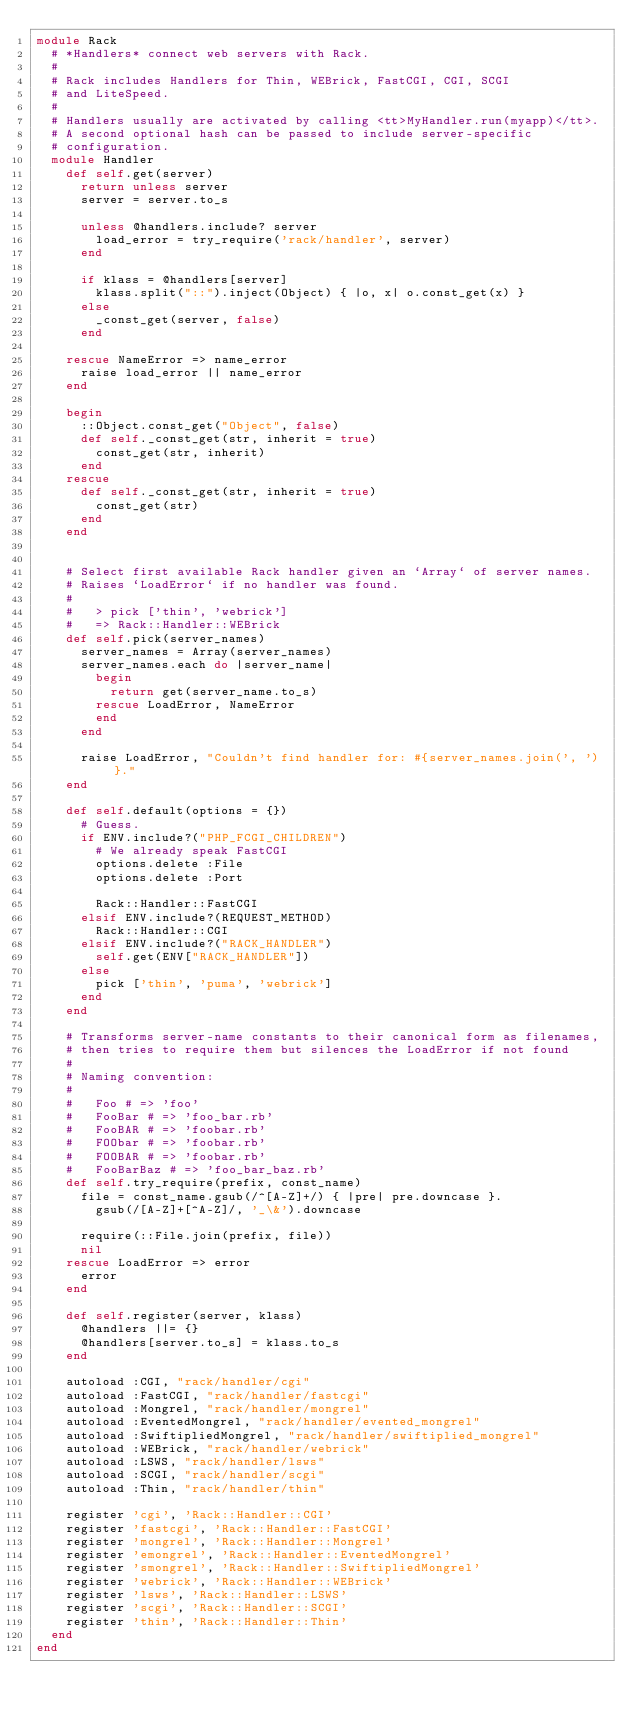<code> <loc_0><loc_0><loc_500><loc_500><_Ruby_>module Rack
  # *Handlers* connect web servers with Rack.
  #
  # Rack includes Handlers for Thin, WEBrick, FastCGI, CGI, SCGI
  # and LiteSpeed.
  #
  # Handlers usually are activated by calling <tt>MyHandler.run(myapp)</tt>.
  # A second optional hash can be passed to include server-specific
  # configuration.
  module Handler
    def self.get(server)
      return unless server
      server = server.to_s

      unless @handlers.include? server
        load_error = try_require('rack/handler', server)
      end

      if klass = @handlers[server]
        klass.split("::").inject(Object) { |o, x| o.const_get(x) }
      else
        _const_get(server, false)
      end

    rescue NameError => name_error
      raise load_error || name_error
    end

    begin
      ::Object.const_get("Object", false)
      def self._const_get(str, inherit = true)
        const_get(str, inherit)
      end
    rescue
      def self._const_get(str, inherit = true)
        const_get(str)
      end
    end


    # Select first available Rack handler given an `Array` of server names.
    # Raises `LoadError` if no handler was found.
    #
    #   > pick ['thin', 'webrick']
    #   => Rack::Handler::WEBrick
    def self.pick(server_names)
      server_names = Array(server_names)
      server_names.each do |server_name|
        begin
          return get(server_name.to_s)
        rescue LoadError, NameError
        end
      end

      raise LoadError, "Couldn't find handler for: #{server_names.join(', ')}."
    end

    def self.default(options = {})
      # Guess.
      if ENV.include?("PHP_FCGI_CHILDREN")
        # We already speak FastCGI
        options.delete :File
        options.delete :Port

        Rack::Handler::FastCGI
      elsif ENV.include?(REQUEST_METHOD)
        Rack::Handler::CGI
      elsif ENV.include?("RACK_HANDLER")
        self.get(ENV["RACK_HANDLER"])
      else
        pick ['thin', 'puma', 'webrick']
      end
    end

    # Transforms server-name constants to their canonical form as filenames,
    # then tries to require them but silences the LoadError if not found
    #
    # Naming convention:
    #
    #   Foo # => 'foo'
    #   FooBar # => 'foo_bar.rb'
    #   FooBAR # => 'foobar.rb'
    #   FOObar # => 'foobar.rb'
    #   FOOBAR # => 'foobar.rb'
    #   FooBarBaz # => 'foo_bar_baz.rb'
    def self.try_require(prefix, const_name)
      file = const_name.gsub(/^[A-Z]+/) { |pre| pre.downcase }.
        gsub(/[A-Z]+[^A-Z]/, '_\&').downcase

      require(::File.join(prefix, file))
      nil
    rescue LoadError => error
      error
    end

    def self.register(server, klass)
      @handlers ||= {}
      @handlers[server.to_s] = klass.to_s
    end

    autoload :CGI, "rack/handler/cgi"
    autoload :FastCGI, "rack/handler/fastcgi"
    autoload :Mongrel, "rack/handler/mongrel"
    autoload :EventedMongrel, "rack/handler/evented_mongrel"
    autoload :SwiftipliedMongrel, "rack/handler/swiftiplied_mongrel"
    autoload :WEBrick, "rack/handler/webrick"
    autoload :LSWS, "rack/handler/lsws"
    autoload :SCGI, "rack/handler/scgi"
    autoload :Thin, "rack/handler/thin"

    register 'cgi', 'Rack::Handler::CGI'
    register 'fastcgi', 'Rack::Handler::FastCGI'
    register 'mongrel', 'Rack::Handler::Mongrel'
    register 'emongrel', 'Rack::Handler::EventedMongrel'
    register 'smongrel', 'Rack::Handler::SwiftipliedMongrel'
    register 'webrick', 'Rack::Handler::WEBrick'
    register 'lsws', 'Rack::Handler::LSWS'
    register 'scgi', 'Rack::Handler::SCGI'
    register 'thin', 'Rack::Handler::Thin'
  end
end
</code> 